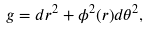<formula> <loc_0><loc_0><loc_500><loc_500>g = d r ^ { 2 } + \phi ^ { 2 } ( r ) d \theta ^ { 2 } ,</formula> 